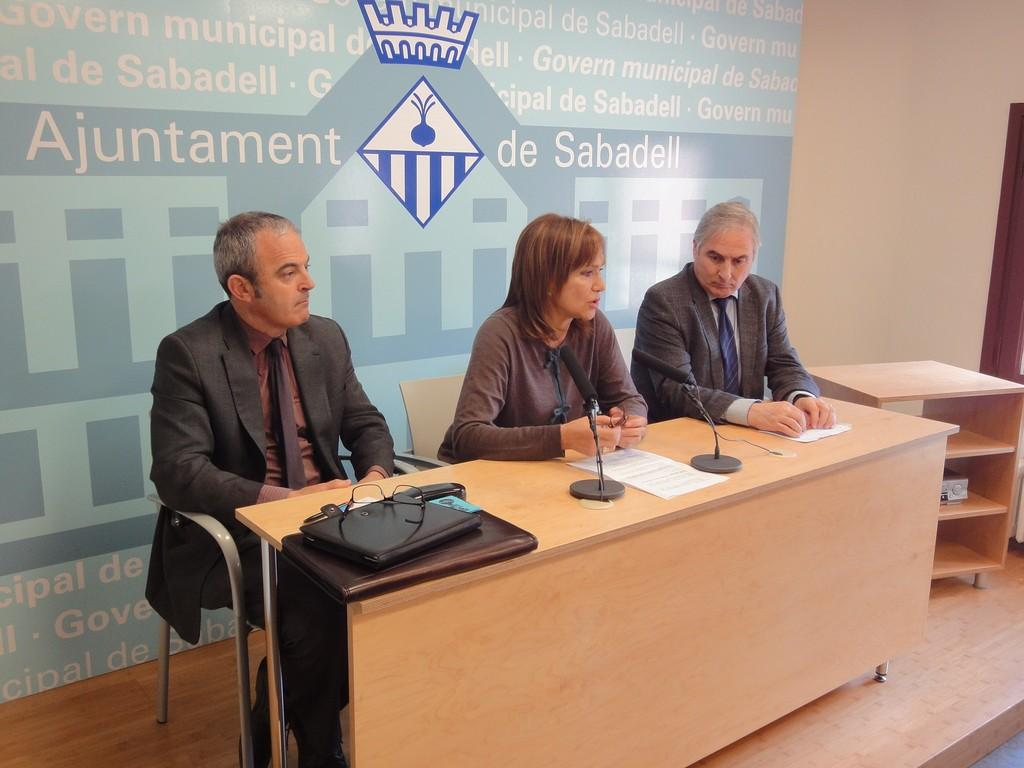How many people are in the image? There are two men and one woman in the image. What are the individuals doing in the image? The individuals are sitting on chairs. What is in front of the people? There is a table in front of them. What is the woman holding in the image? The woman is holding a microphone. What can be found on the table? There are multiple items on the table. What type of beef is being served on the table in the image? There is no beef present in the image. How many chickens are visible in the image? There are no chickens visible in the image. 